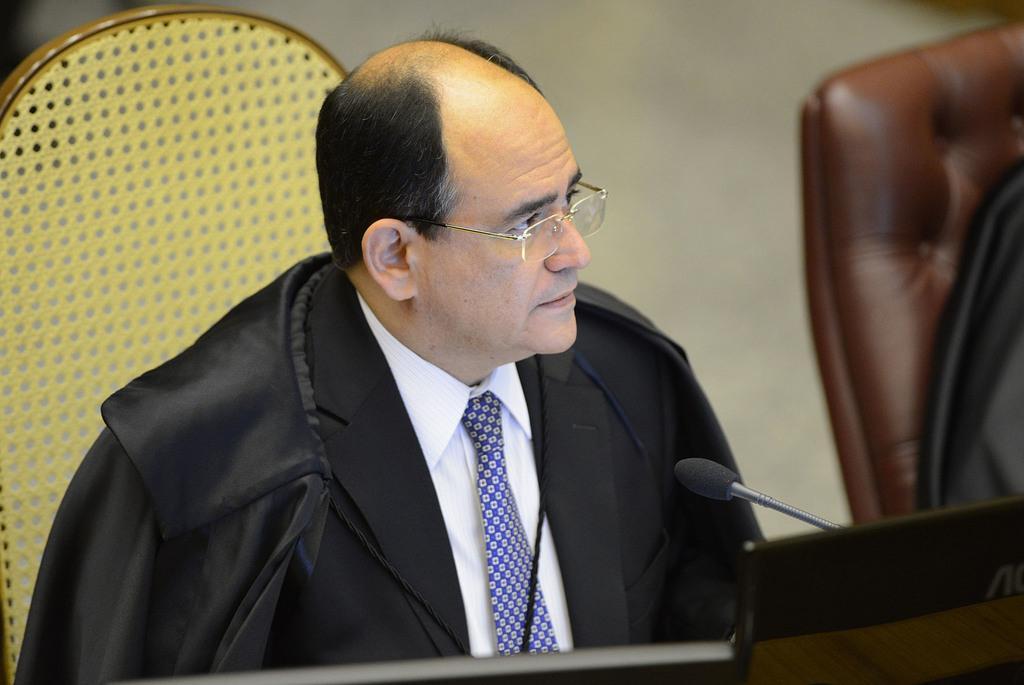In one or two sentences, can you explain what this image depicts? In this image there is a person with black suit and white shirt sitting on a chair. There is a microphone in the image. 